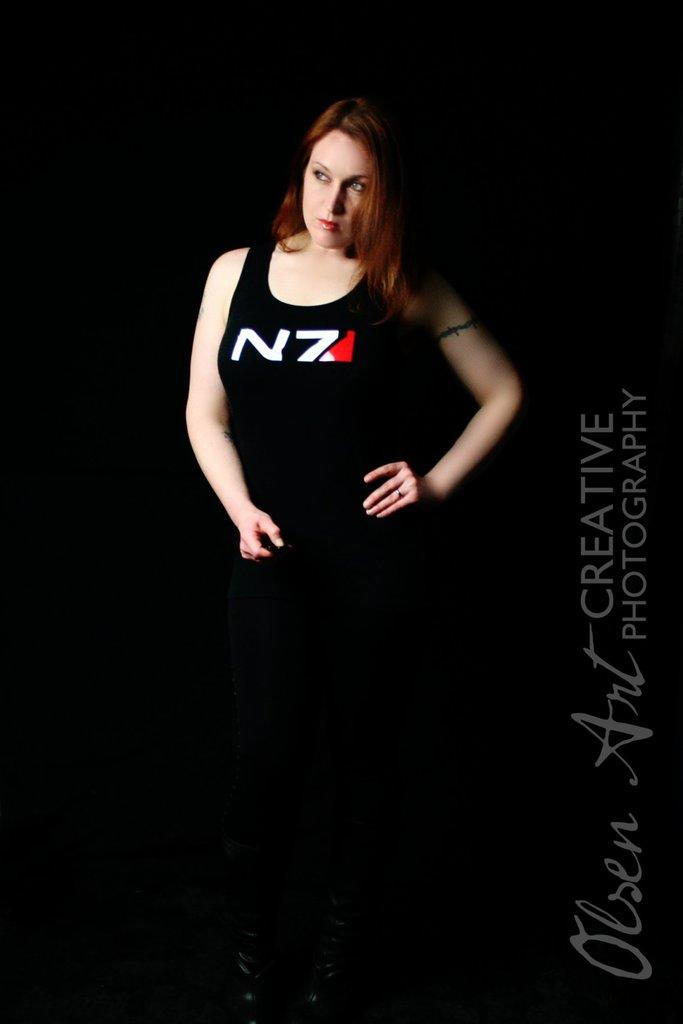What is the main subject of the image? There is a person in the image. What else can be seen on the right side of the image? There is text visible on the right side of the image. What is the color of the background in the image? The background of the image is dark. What type of distribution is the farmer making in the image? There is no farmer or distribution activity present in the image. 